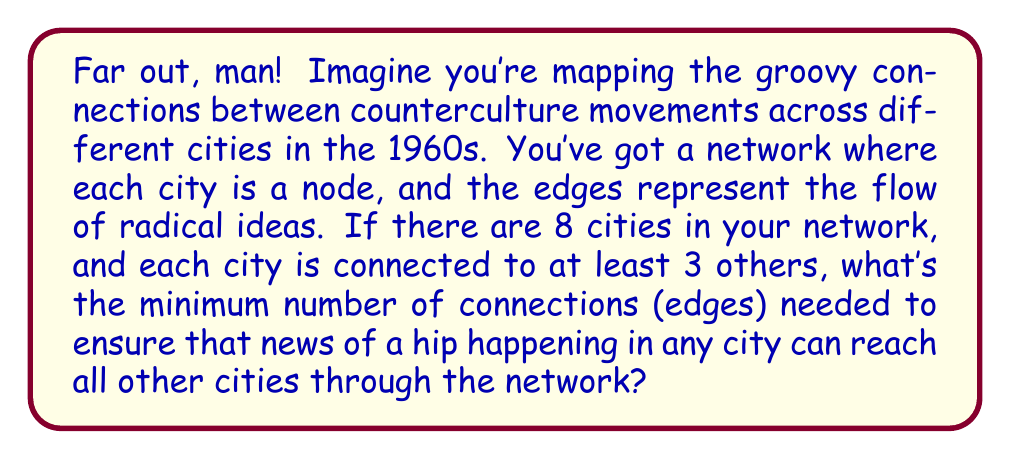What is the answer to this math problem? Alright, let's dive into this cosmic puzzle, cats and kittens!

1) First, we need to understand what we're dealing with in the language of topology:
   - We have a graph with 8 vertices (cities)
   - Each vertex has a degree of at least 3 (connected to at least 3 others)
   - We want the graph to be connected (all cities can communicate)

2) Now, the groovy thing about connectivity is that we need at least (n-1) edges to connect n vertices. That's our starting point, dig?

3) But here's the twist: we need each city to have at least 3 connections. Let's count:
   - With 8 cities, we need at least 8 * 3 = 24 connections
   - But wait! This counts each connection twice (once for each city it connects)
   - So we divide by 2: 24 / 2 = 12

4) Now we're groovin'! We know we need at least 12 edges to satisfy the degree requirement.

5) But is 12 enough to connect all cities? Let's check:
   - Remember, we need at least (n-1) = 7 edges for connectivity
   - 12 is more than 7, so we're cool, man!

6) Can we reduce this number? Nope! If we remove any edge, we'll have a city with only 2 connections, and that's not our scene.

So, 12 is our magic number. It's the minimum that satisfies both our connectivity need and the degree requirement. It's like finding the perfect harmony in a jazz improvisation, you dig?
Answer: The minimum number of connections needed is 12. 